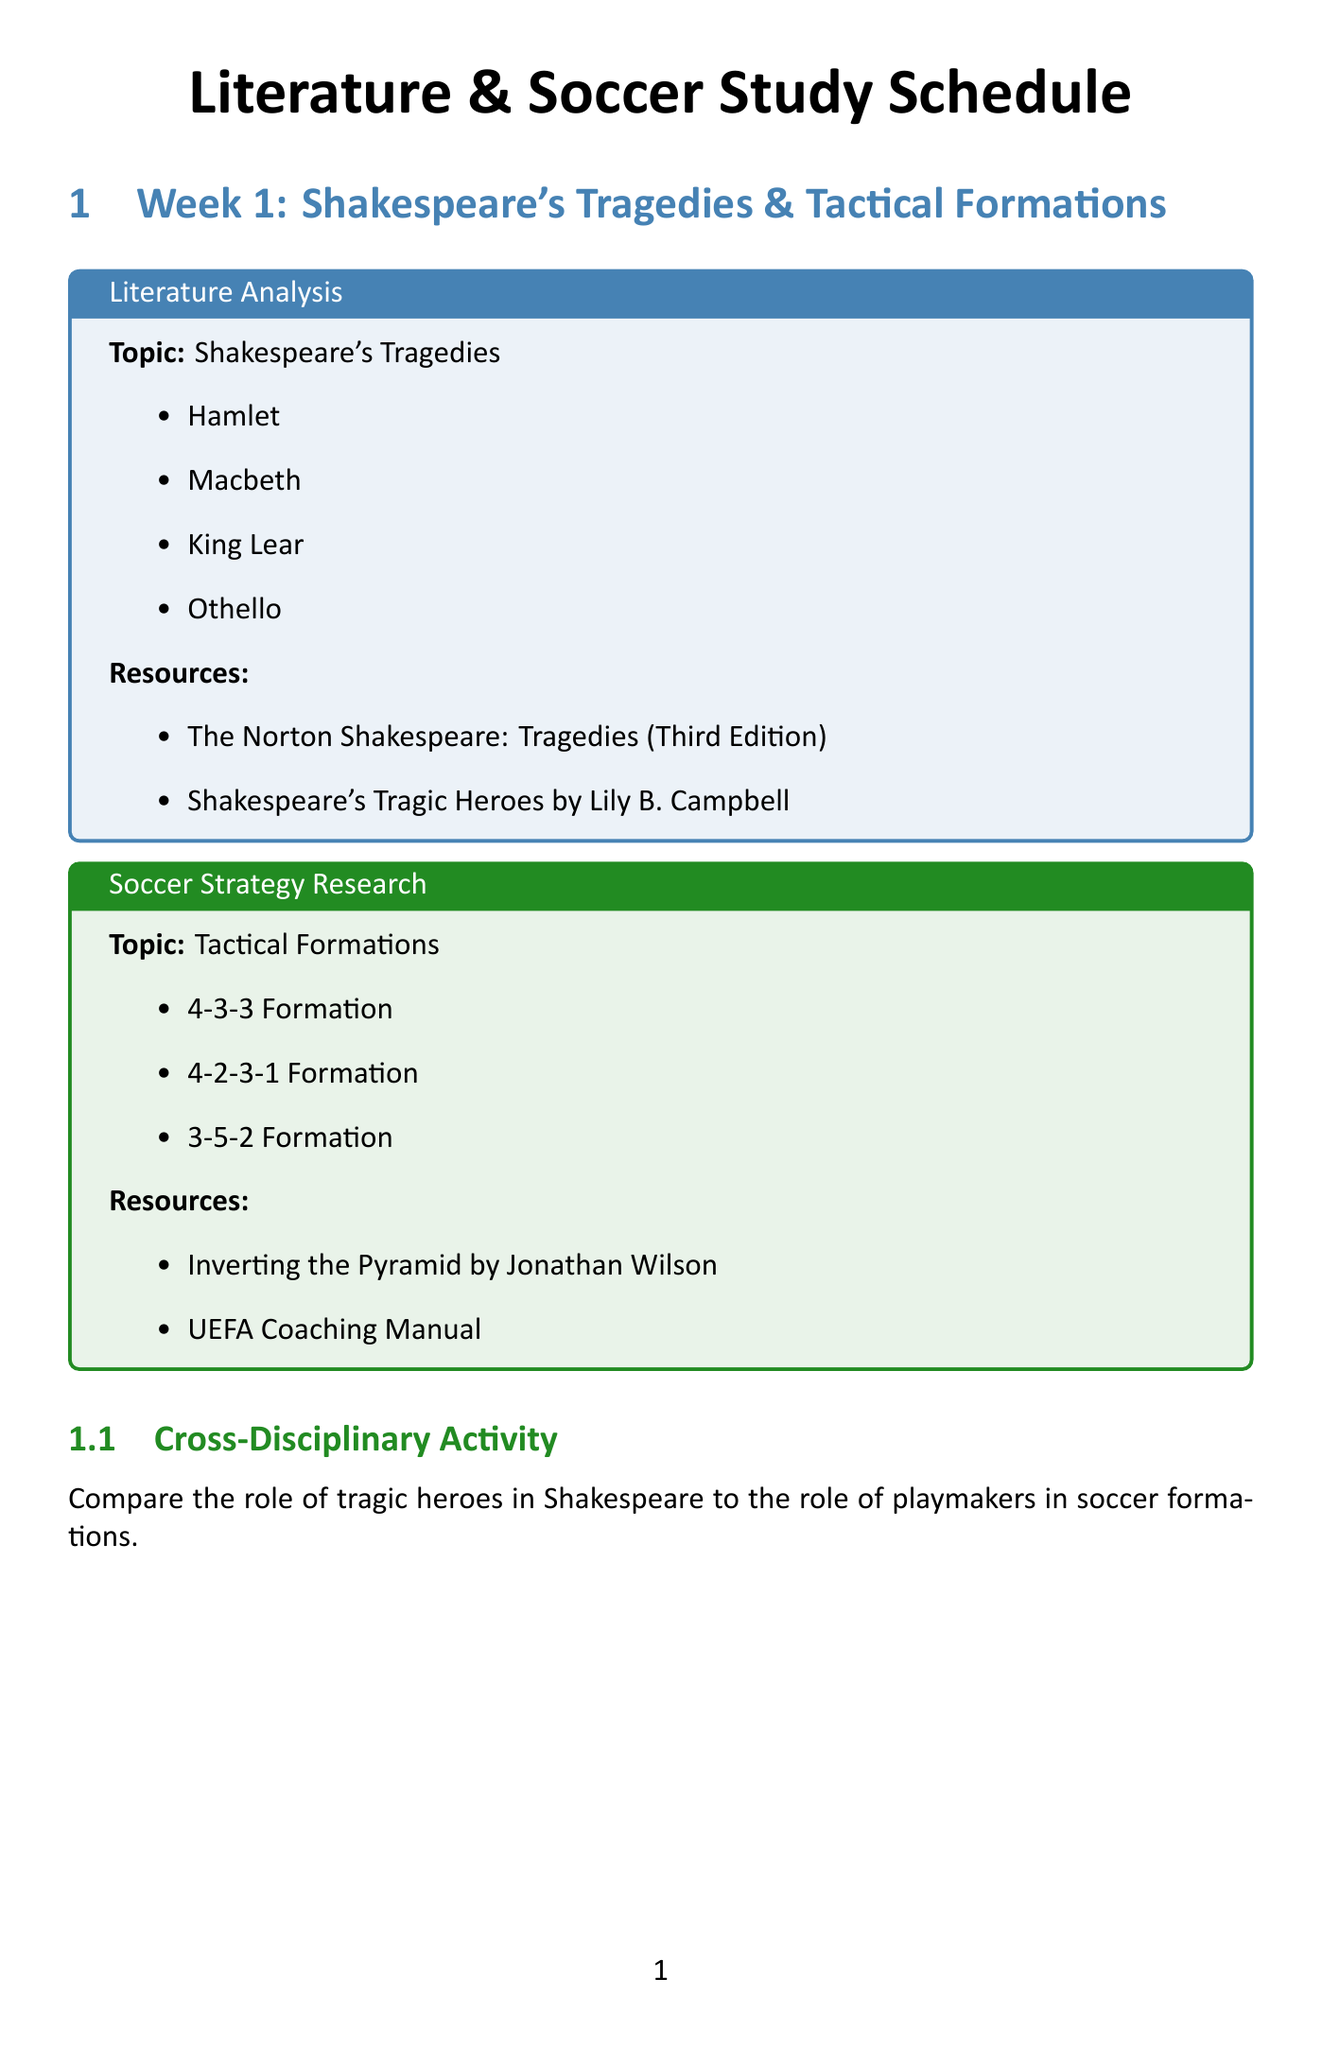What is the first topic of Week 1? The document specifies that the first topic of Week 1 is "Shakespeare's Tragedies."
Answer: Shakespeare's Tragedies How many subtopics are there under Modernist Literature? The document lists three subtopics under Modernist Literature: Ulysses, Mrs. Dalloway, and The Waste Land.
Answer: three What are the two resources for Pressing Techniques? The document provides two resources for Pressing Techniques: "Gegenpressing: The German Soccer Revolution" and "Pep Guardiola: The Evolution."
Answer: Gegenpressing: The German Soccer Revolution, Pep Guardiola: The Evolution Which soccer strategy is explored in Week 3? In Week 3, the document focuses on "Set-Piece Strategies" as the soccer strategy.
Answer: Set-Piece Strategies Identify one cross-disciplinary activity mentioned. The document lists several cross-disciplinary activities, one of which is to "Analyze soccer-themed literature."
Answer: Analyze soccer-themed literature What is one example of a subtopic under Tactical Formations? The document mentions three subtopics under Tactical Formations, one of which is "4-2-3-1 Formation."
Answer: 4-2-3-1 Formation How many weeks are covered in the study schedule? The document outlines three weeks of study in total.
Answer: three What type of literature is analyzed in Week 2? The document indicates that "Modernist Literature" is the type of literature analyzed in Week 2.
Answer: Modernist Literature 